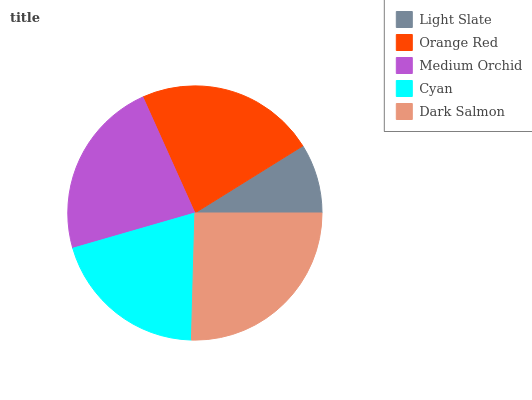Is Light Slate the minimum?
Answer yes or no. Yes. Is Dark Salmon the maximum?
Answer yes or no. Yes. Is Orange Red the minimum?
Answer yes or no. No. Is Orange Red the maximum?
Answer yes or no. No. Is Orange Red greater than Light Slate?
Answer yes or no. Yes. Is Light Slate less than Orange Red?
Answer yes or no. Yes. Is Light Slate greater than Orange Red?
Answer yes or no. No. Is Orange Red less than Light Slate?
Answer yes or no. No. Is Medium Orchid the high median?
Answer yes or no. Yes. Is Medium Orchid the low median?
Answer yes or no. Yes. Is Orange Red the high median?
Answer yes or no. No. Is Orange Red the low median?
Answer yes or no. No. 